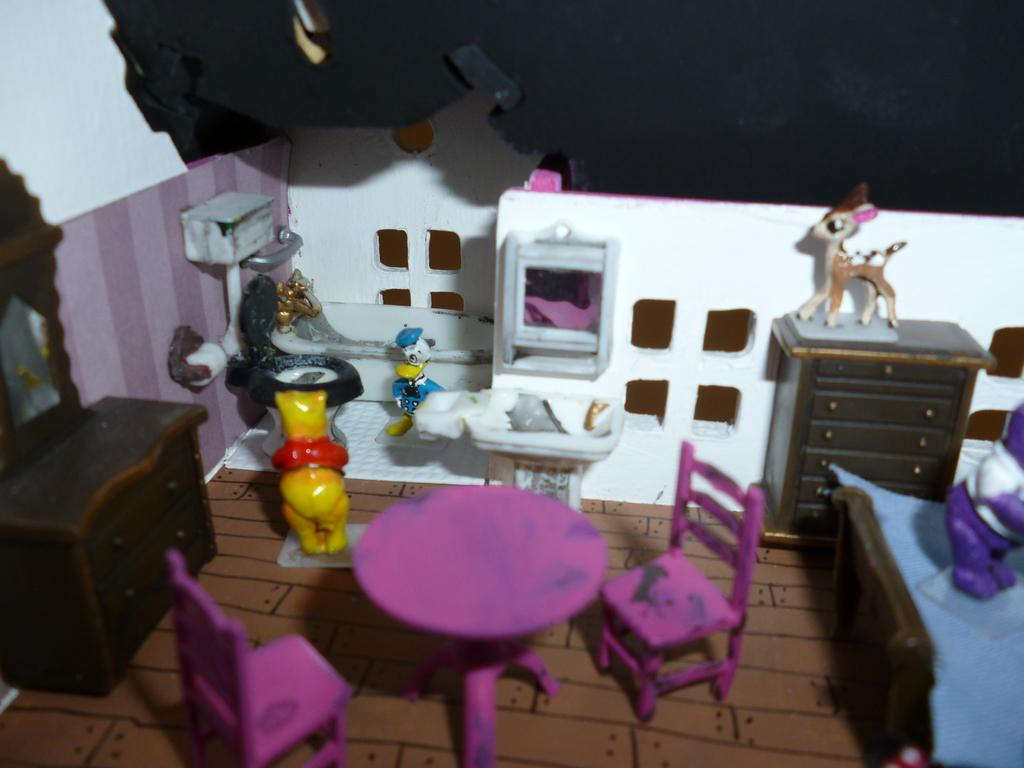What type of furniture is present in the image? There is a table, a chair, and a dressing table in the image. What other fixtures can be seen in the image? There is a sink, a toilet, and a mirror in the image. What type of bed is in the image? There is a bed in the image. What object is on the floor in the image? There is a toy on the floor in the image. What type of tank is visible in the image? There is no tank present in the image. How many ducks are swimming in the toilet in the image? There are no ducks present in the image, and the toilet is not a body of water where ducks would swim. 